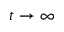<formula> <loc_0><loc_0><loc_500><loc_500>t \rightarrow \infty</formula> 